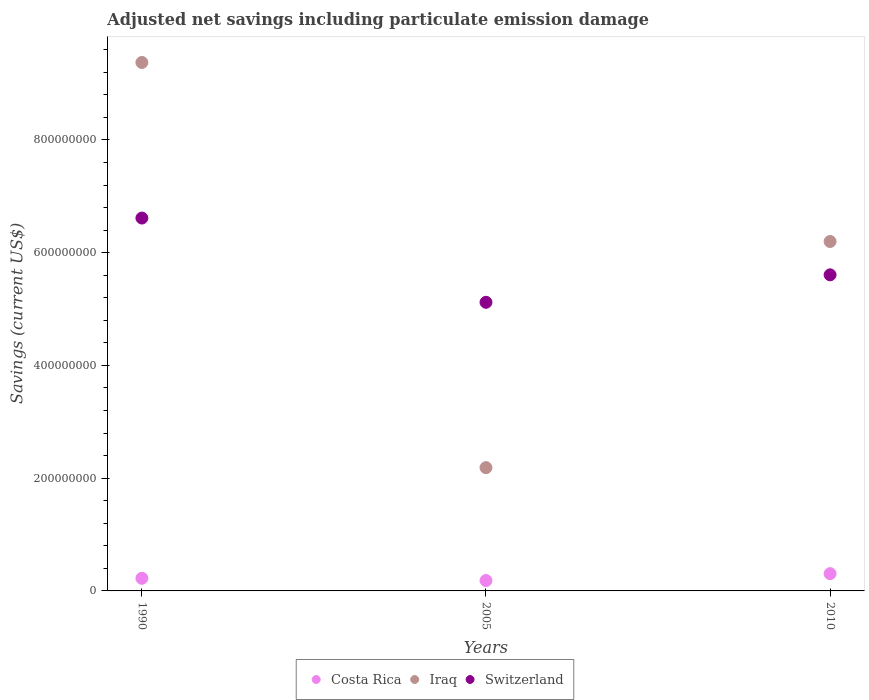What is the net savings in Costa Rica in 2005?
Make the answer very short. 1.84e+07. Across all years, what is the maximum net savings in Costa Rica?
Ensure brevity in your answer.  3.07e+07. Across all years, what is the minimum net savings in Switzerland?
Make the answer very short. 5.12e+08. In which year was the net savings in Costa Rica maximum?
Your answer should be compact. 2010. In which year was the net savings in Iraq minimum?
Provide a succinct answer. 2005. What is the total net savings in Switzerland in the graph?
Provide a succinct answer. 1.73e+09. What is the difference between the net savings in Switzerland in 1990 and that in 2005?
Ensure brevity in your answer.  1.49e+08. What is the difference between the net savings in Switzerland in 2005 and the net savings in Iraq in 2010?
Offer a very short reply. -1.08e+08. What is the average net savings in Costa Rica per year?
Provide a succinct answer. 2.38e+07. In the year 1990, what is the difference between the net savings in Costa Rica and net savings in Switzerland?
Your answer should be compact. -6.39e+08. In how many years, is the net savings in Switzerland greater than 240000000 US$?
Provide a short and direct response. 3. What is the ratio of the net savings in Switzerland in 1990 to that in 2005?
Your response must be concise. 1.29. What is the difference between the highest and the second highest net savings in Costa Rica?
Your response must be concise. 8.24e+06. What is the difference between the highest and the lowest net savings in Iraq?
Your response must be concise. 7.19e+08. Is the sum of the net savings in Costa Rica in 1990 and 2005 greater than the maximum net savings in Iraq across all years?
Make the answer very short. No. Is it the case that in every year, the sum of the net savings in Iraq and net savings in Switzerland  is greater than the net savings in Costa Rica?
Your answer should be very brief. Yes. Does the net savings in Iraq monotonically increase over the years?
Ensure brevity in your answer.  No. Is the net savings in Iraq strictly greater than the net savings in Switzerland over the years?
Ensure brevity in your answer.  No. How many years are there in the graph?
Make the answer very short. 3. What is the difference between two consecutive major ticks on the Y-axis?
Make the answer very short. 2.00e+08. Does the graph contain any zero values?
Offer a very short reply. No. Does the graph contain grids?
Ensure brevity in your answer.  No. What is the title of the graph?
Give a very brief answer. Adjusted net savings including particulate emission damage. Does "Moldova" appear as one of the legend labels in the graph?
Offer a very short reply. No. What is the label or title of the X-axis?
Keep it short and to the point. Years. What is the label or title of the Y-axis?
Ensure brevity in your answer.  Savings (current US$). What is the Savings (current US$) of Costa Rica in 1990?
Offer a very short reply. 2.24e+07. What is the Savings (current US$) in Iraq in 1990?
Your answer should be very brief. 9.38e+08. What is the Savings (current US$) of Switzerland in 1990?
Your answer should be very brief. 6.61e+08. What is the Savings (current US$) of Costa Rica in 2005?
Your answer should be compact. 1.84e+07. What is the Savings (current US$) of Iraq in 2005?
Provide a succinct answer. 2.19e+08. What is the Savings (current US$) in Switzerland in 2005?
Ensure brevity in your answer.  5.12e+08. What is the Savings (current US$) of Costa Rica in 2010?
Your response must be concise. 3.07e+07. What is the Savings (current US$) of Iraq in 2010?
Offer a very short reply. 6.20e+08. What is the Savings (current US$) in Switzerland in 2010?
Offer a very short reply. 5.61e+08. Across all years, what is the maximum Savings (current US$) in Costa Rica?
Provide a short and direct response. 3.07e+07. Across all years, what is the maximum Savings (current US$) in Iraq?
Offer a very short reply. 9.38e+08. Across all years, what is the maximum Savings (current US$) of Switzerland?
Give a very brief answer. 6.61e+08. Across all years, what is the minimum Savings (current US$) of Costa Rica?
Provide a short and direct response. 1.84e+07. Across all years, what is the minimum Savings (current US$) in Iraq?
Ensure brevity in your answer.  2.19e+08. Across all years, what is the minimum Savings (current US$) of Switzerland?
Give a very brief answer. 5.12e+08. What is the total Savings (current US$) of Costa Rica in the graph?
Your answer should be very brief. 7.15e+07. What is the total Savings (current US$) in Iraq in the graph?
Your answer should be compact. 1.78e+09. What is the total Savings (current US$) of Switzerland in the graph?
Your response must be concise. 1.73e+09. What is the difference between the Savings (current US$) in Costa Rica in 1990 and that in 2005?
Provide a short and direct response. 3.99e+06. What is the difference between the Savings (current US$) of Iraq in 1990 and that in 2005?
Offer a very short reply. 7.19e+08. What is the difference between the Savings (current US$) of Switzerland in 1990 and that in 2005?
Ensure brevity in your answer.  1.49e+08. What is the difference between the Savings (current US$) of Costa Rica in 1990 and that in 2010?
Your answer should be compact. -8.24e+06. What is the difference between the Savings (current US$) in Iraq in 1990 and that in 2010?
Keep it short and to the point. 3.18e+08. What is the difference between the Savings (current US$) of Switzerland in 1990 and that in 2010?
Give a very brief answer. 1.01e+08. What is the difference between the Savings (current US$) of Costa Rica in 2005 and that in 2010?
Make the answer very short. -1.22e+07. What is the difference between the Savings (current US$) of Iraq in 2005 and that in 2010?
Offer a terse response. -4.01e+08. What is the difference between the Savings (current US$) in Switzerland in 2005 and that in 2010?
Offer a terse response. -4.87e+07. What is the difference between the Savings (current US$) in Costa Rica in 1990 and the Savings (current US$) in Iraq in 2005?
Your answer should be compact. -1.96e+08. What is the difference between the Savings (current US$) in Costa Rica in 1990 and the Savings (current US$) in Switzerland in 2005?
Give a very brief answer. -4.90e+08. What is the difference between the Savings (current US$) in Iraq in 1990 and the Savings (current US$) in Switzerland in 2005?
Your answer should be very brief. 4.25e+08. What is the difference between the Savings (current US$) in Costa Rica in 1990 and the Savings (current US$) in Iraq in 2010?
Provide a short and direct response. -5.97e+08. What is the difference between the Savings (current US$) of Costa Rica in 1990 and the Savings (current US$) of Switzerland in 2010?
Ensure brevity in your answer.  -5.38e+08. What is the difference between the Savings (current US$) in Iraq in 1990 and the Savings (current US$) in Switzerland in 2010?
Your answer should be compact. 3.77e+08. What is the difference between the Savings (current US$) of Costa Rica in 2005 and the Savings (current US$) of Iraq in 2010?
Provide a succinct answer. -6.01e+08. What is the difference between the Savings (current US$) in Costa Rica in 2005 and the Savings (current US$) in Switzerland in 2010?
Offer a very short reply. -5.42e+08. What is the difference between the Savings (current US$) of Iraq in 2005 and the Savings (current US$) of Switzerland in 2010?
Offer a terse response. -3.42e+08. What is the average Savings (current US$) of Costa Rica per year?
Your answer should be very brief. 2.38e+07. What is the average Savings (current US$) in Iraq per year?
Your response must be concise. 5.92e+08. What is the average Savings (current US$) in Switzerland per year?
Your answer should be compact. 5.78e+08. In the year 1990, what is the difference between the Savings (current US$) of Costa Rica and Savings (current US$) of Iraq?
Your answer should be compact. -9.15e+08. In the year 1990, what is the difference between the Savings (current US$) in Costa Rica and Savings (current US$) in Switzerland?
Your answer should be compact. -6.39e+08. In the year 1990, what is the difference between the Savings (current US$) in Iraq and Savings (current US$) in Switzerland?
Give a very brief answer. 2.76e+08. In the year 2005, what is the difference between the Savings (current US$) of Costa Rica and Savings (current US$) of Iraq?
Provide a short and direct response. -2.00e+08. In the year 2005, what is the difference between the Savings (current US$) of Costa Rica and Savings (current US$) of Switzerland?
Provide a succinct answer. -4.94e+08. In the year 2005, what is the difference between the Savings (current US$) of Iraq and Savings (current US$) of Switzerland?
Your answer should be very brief. -2.93e+08. In the year 2010, what is the difference between the Savings (current US$) of Costa Rica and Savings (current US$) of Iraq?
Provide a short and direct response. -5.89e+08. In the year 2010, what is the difference between the Savings (current US$) in Costa Rica and Savings (current US$) in Switzerland?
Provide a succinct answer. -5.30e+08. In the year 2010, what is the difference between the Savings (current US$) in Iraq and Savings (current US$) in Switzerland?
Your answer should be very brief. 5.91e+07. What is the ratio of the Savings (current US$) of Costa Rica in 1990 to that in 2005?
Your answer should be very brief. 1.22. What is the ratio of the Savings (current US$) in Iraq in 1990 to that in 2005?
Keep it short and to the point. 4.29. What is the ratio of the Savings (current US$) in Switzerland in 1990 to that in 2005?
Make the answer very short. 1.29. What is the ratio of the Savings (current US$) of Costa Rica in 1990 to that in 2010?
Keep it short and to the point. 0.73. What is the ratio of the Savings (current US$) in Iraq in 1990 to that in 2010?
Make the answer very short. 1.51. What is the ratio of the Savings (current US$) of Switzerland in 1990 to that in 2010?
Give a very brief answer. 1.18. What is the ratio of the Savings (current US$) in Costa Rica in 2005 to that in 2010?
Offer a terse response. 0.6. What is the ratio of the Savings (current US$) of Iraq in 2005 to that in 2010?
Your answer should be very brief. 0.35. What is the ratio of the Savings (current US$) in Switzerland in 2005 to that in 2010?
Give a very brief answer. 0.91. What is the difference between the highest and the second highest Savings (current US$) of Costa Rica?
Make the answer very short. 8.24e+06. What is the difference between the highest and the second highest Savings (current US$) of Iraq?
Your answer should be very brief. 3.18e+08. What is the difference between the highest and the second highest Savings (current US$) of Switzerland?
Offer a terse response. 1.01e+08. What is the difference between the highest and the lowest Savings (current US$) in Costa Rica?
Your answer should be compact. 1.22e+07. What is the difference between the highest and the lowest Savings (current US$) in Iraq?
Give a very brief answer. 7.19e+08. What is the difference between the highest and the lowest Savings (current US$) of Switzerland?
Provide a succinct answer. 1.49e+08. 